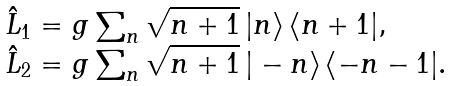Convert formula to latex. <formula><loc_0><loc_0><loc_500><loc_500>\begin{array} { l } \hat { L } _ { 1 } = g \sum _ { n } \sqrt { n + 1 } \, | n \rangle \, \langle n + 1 | , \\ \hat { L } _ { 2 } = g \sum _ { n } \sqrt { n + 1 } \, | - n \rangle \, \langle - n - 1 | . \end{array}</formula> 